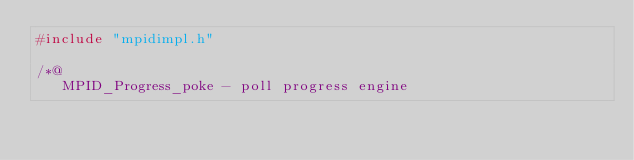Convert code to text. <code><loc_0><loc_0><loc_500><loc_500><_C_>#include "mpidimpl.h"

/*@
   MPID_Progress_poke - poll progress engine
</code> 